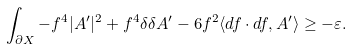Convert formula to latex. <formula><loc_0><loc_0><loc_500><loc_500>\int _ { \partial X } - f ^ { 4 } | A ^ { \prime } | ^ { 2 } + f ^ { 4 } \delta \delta A ^ { \prime } - 6 f ^ { 2 } \langle d f \cdot d f , A ^ { \prime } \rangle \geq - \varepsilon .</formula> 